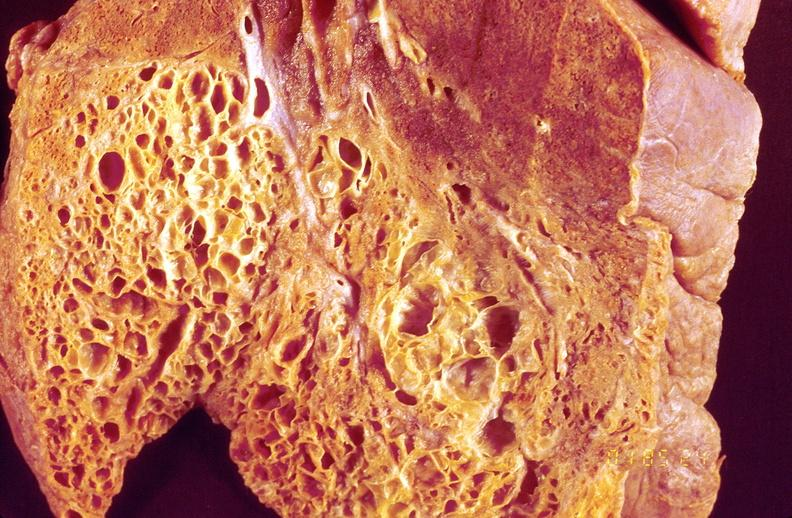what is present?
Answer the question using a single word or phrase. Respiratory 